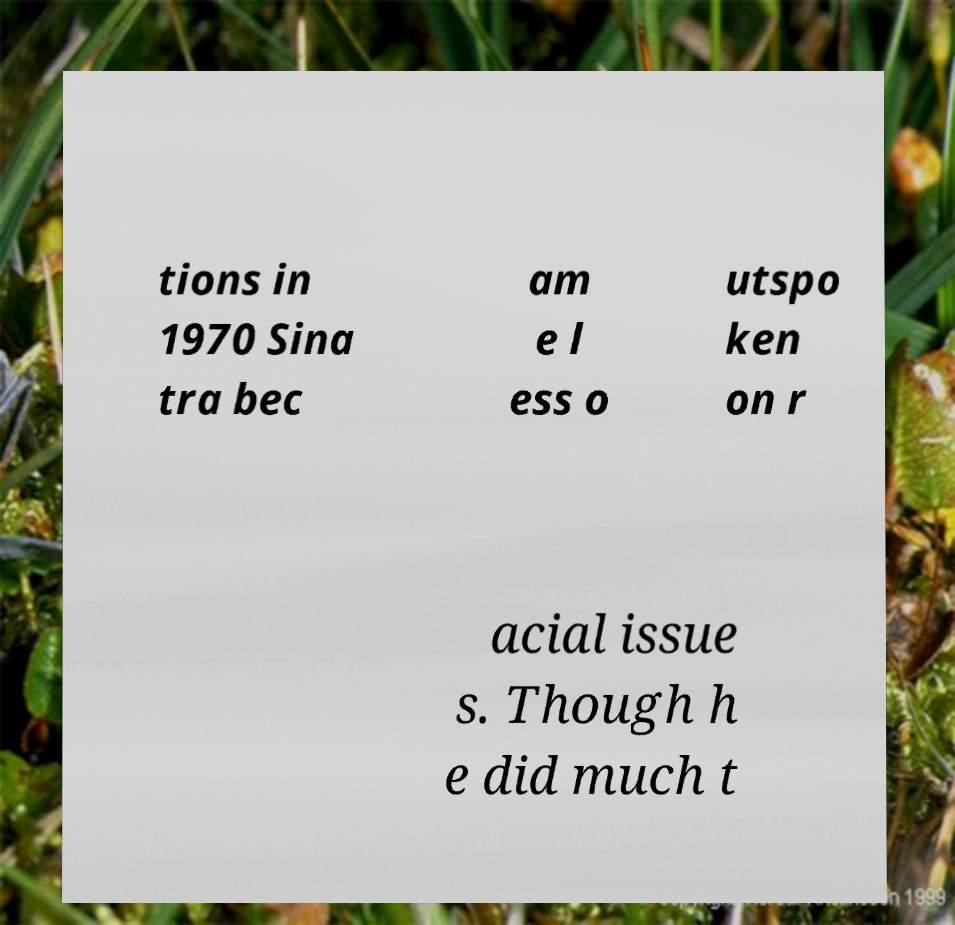Please read and relay the text visible in this image. What does it say? tions in 1970 Sina tra bec am e l ess o utspo ken on r acial issue s. Though h e did much t 